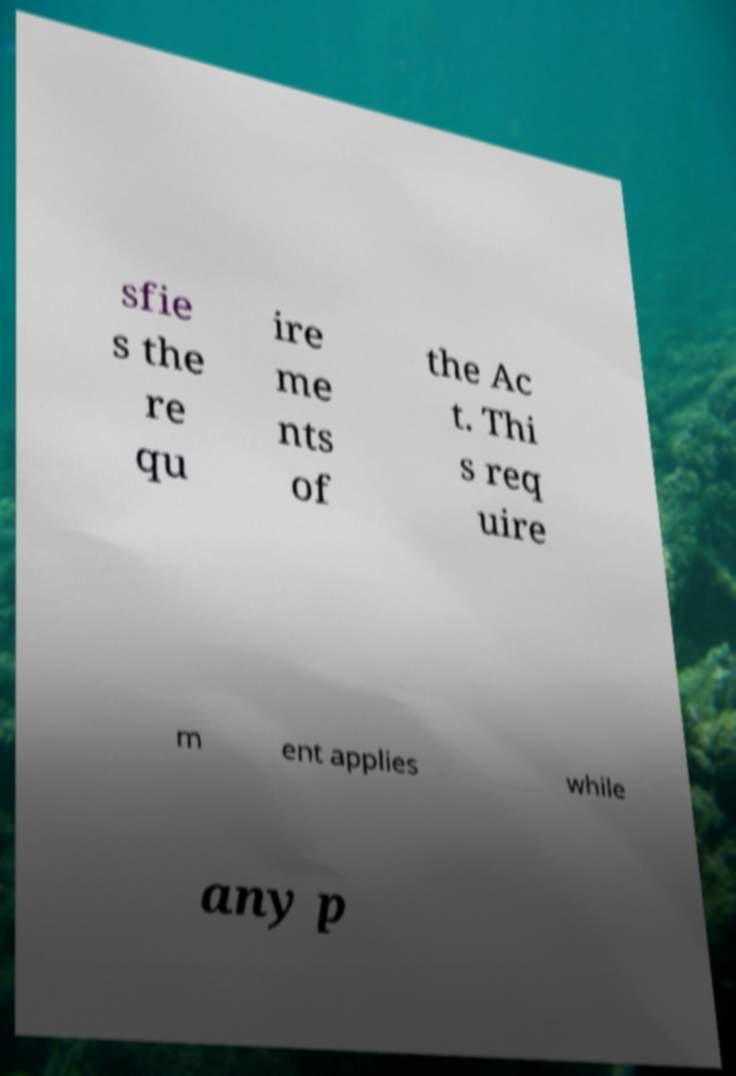Could you extract and type out the text from this image? sfie s the re qu ire me nts of the Ac t. Thi s req uire m ent applies while any p 